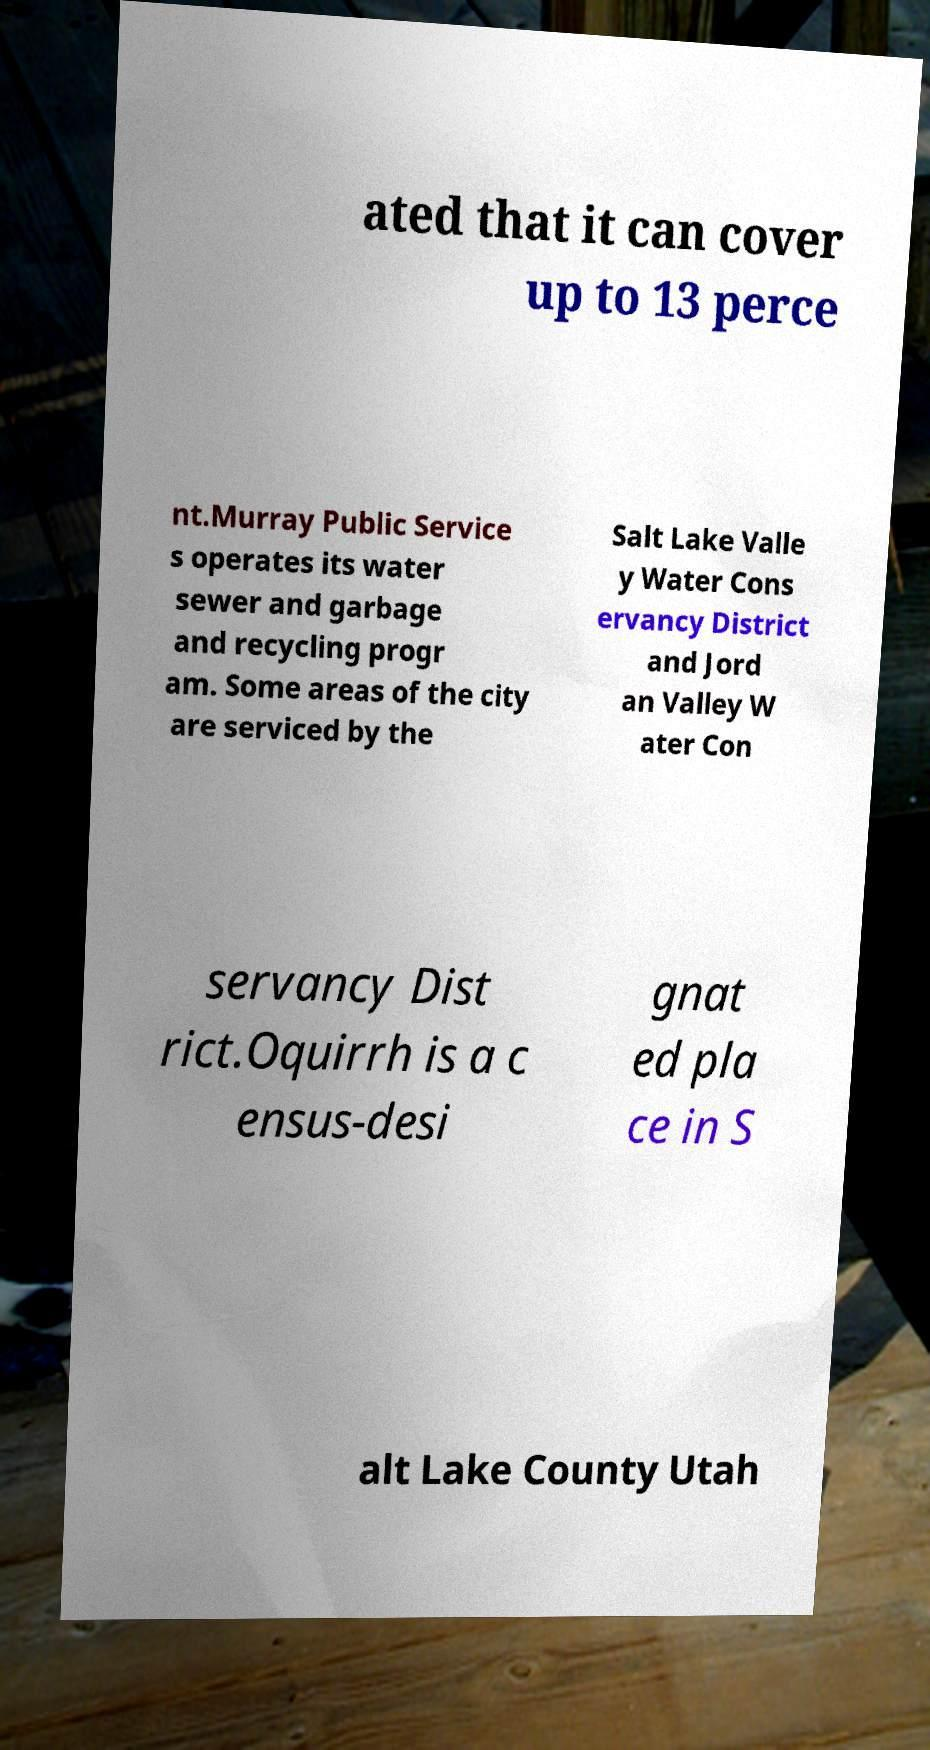Can you accurately transcribe the text from the provided image for me? ated that it can cover up to 13 perce nt.Murray Public Service s operates its water sewer and garbage and recycling progr am. Some areas of the city are serviced by the Salt Lake Valle y Water Cons ervancy District and Jord an Valley W ater Con servancy Dist rict.Oquirrh is a c ensus-desi gnat ed pla ce in S alt Lake County Utah 